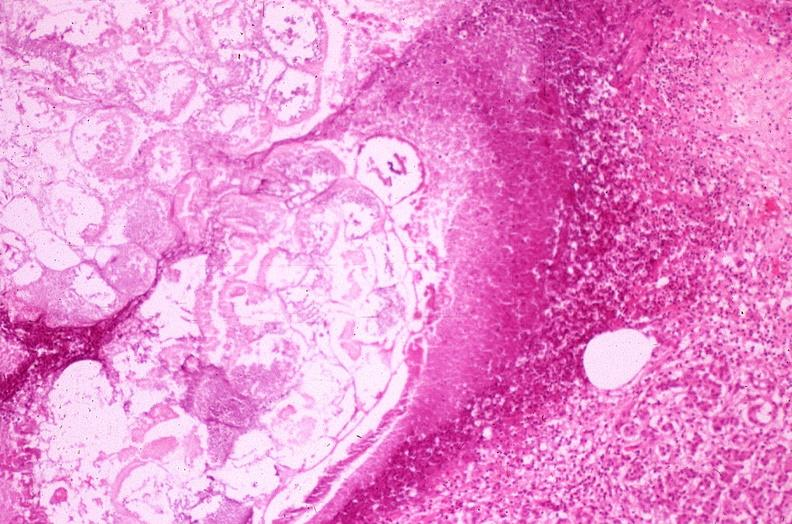what does this image show?
Answer the question using a single word or phrase. Pancreatic fat necrosis 